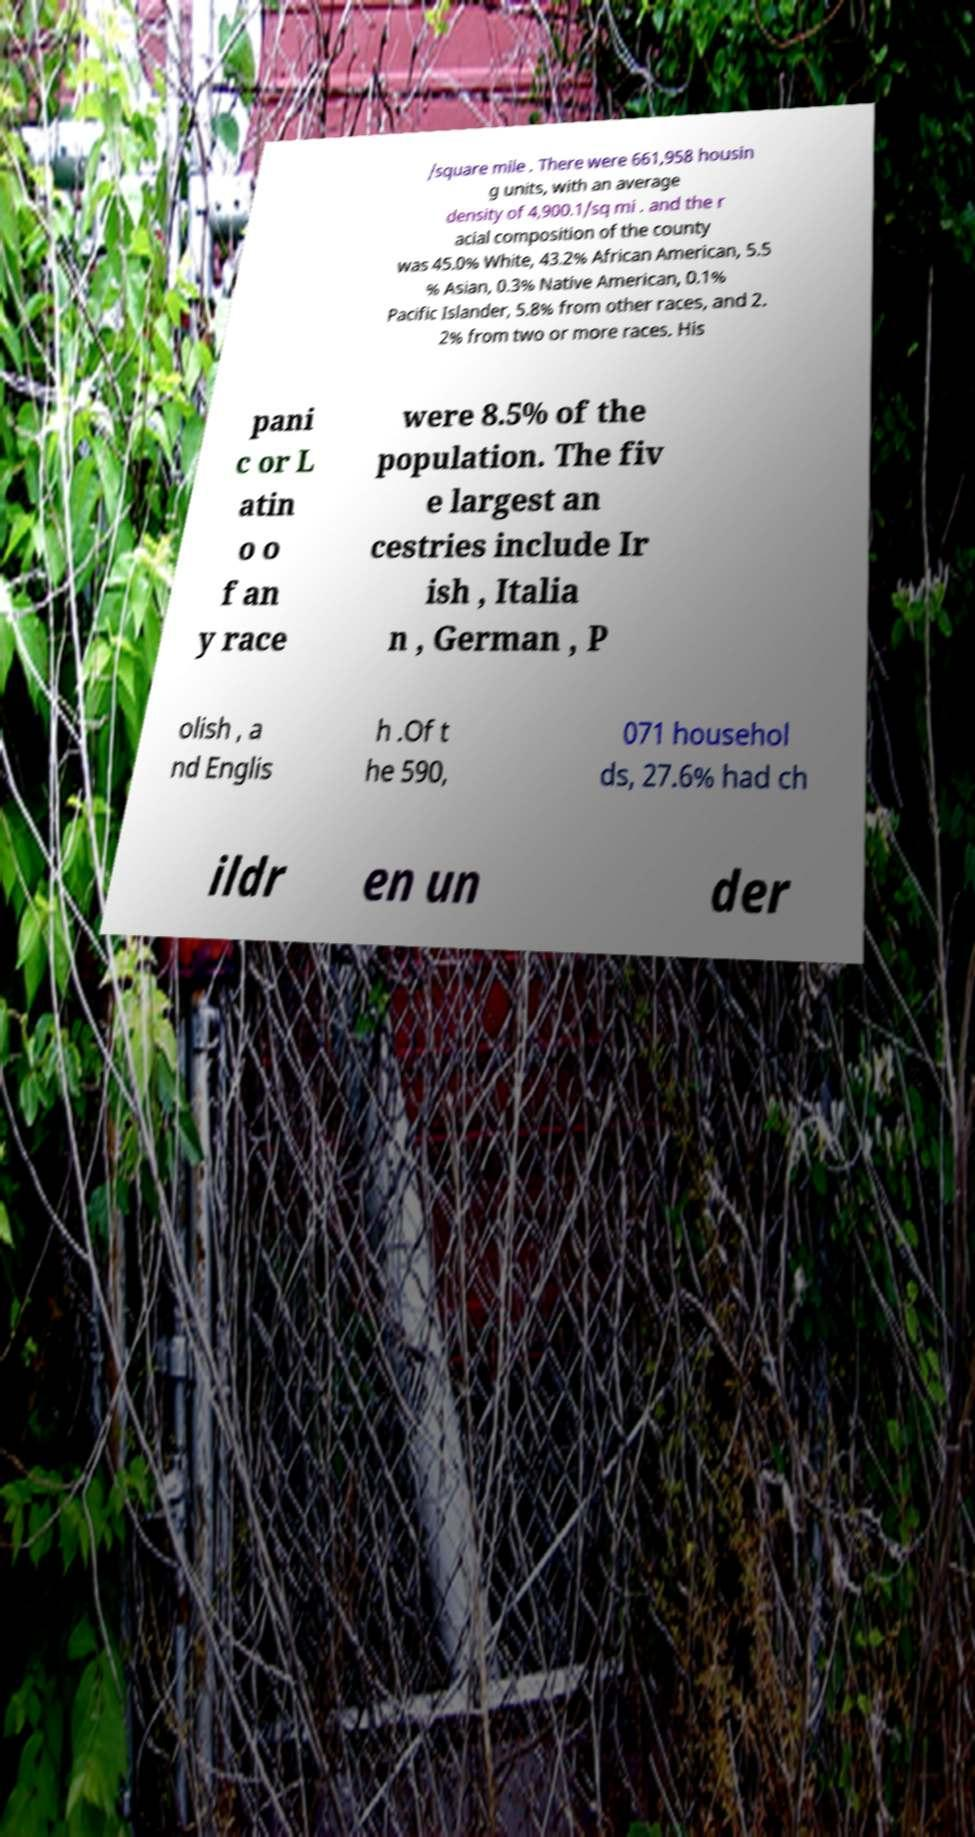Can you accurately transcribe the text from the provided image for me? /square mile . There were 661,958 housin g units, with an average density of 4,900.1/sq mi . and the r acial composition of the county was 45.0% White, 43.2% African American, 5.5 % Asian, 0.3% Native American, 0.1% Pacific Islander, 5.8% from other races, and 2. 2% from two or more races. His pani c or L atin o o f an y race were 8.5% of the population. The fiv e largest an cestries include Ir ish , Italia n , German , P olish , a nd Englis h .Of t he 590, 071 househol ds, 27.6% had ch ildr en un der 